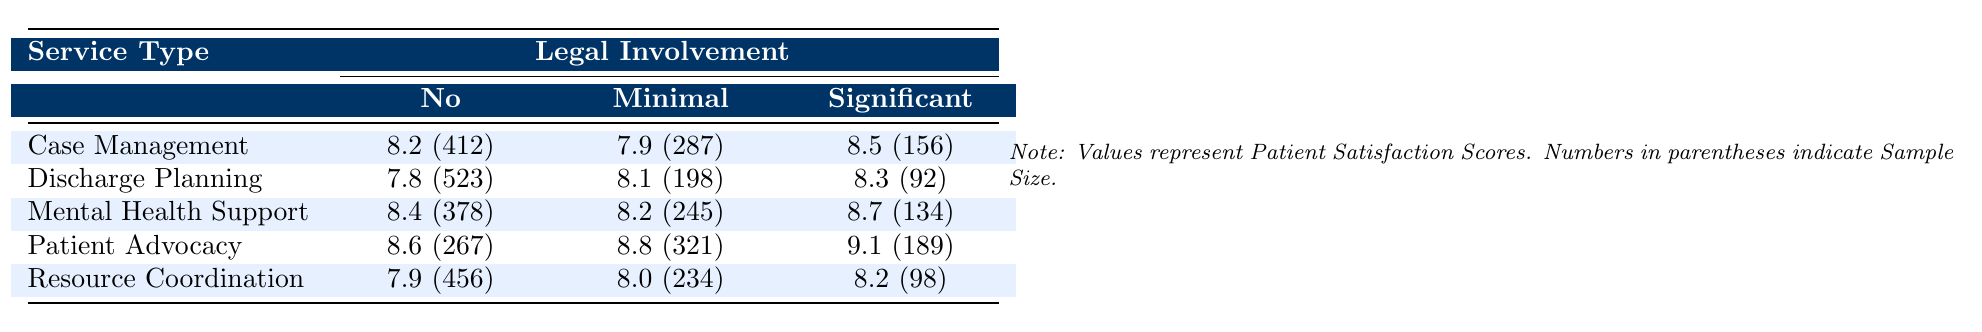What is the satisfaction score for Case Management with No Legal Involvement? The satisfaction score listed under Case Management for No Legal Involvement is 8.2.
Answer: 8.2 How many patients participated in the Discharge Planning with Significant Legal Involvement? The sample size for Discharge Planning with Significant Legal Involvement is 92 patients.
Answer: 92 What is the highest satisfaction score among the service types? The highest satisfaction score is 9.1 for Patient Advocacy with Significant Legal Involvement.
Answer: 9.1 What is the average satisfaction score for Mental Health Support across all levels of legal involvement? The scores are 8.4, 8.2, and 8.7 for the three levels. Summing them gives 25.3, and dividing by 3 results in an average score of approximately 8.43.
Answer: 8.43 Is the satisfaction score for Resource Coordination with Minimal Legal Involvement higher than that for Case Management with No Legal Involvement? The satisfaction score for Resource Coordination with Minimal Legal Involvement is 8.0, while Case Management with No Legal Involvement is 8.2, so it is not higher.
Answer: No Which service type has the lowest satisfaction score when there is Significant Legal Involvement? For Significant Legal Involvement, the satisfaction scores are 8.5 (Case Management), 8.3 (Discharge Planning), 8.7 (Mental Health Support), 9.1 (Patient Advocacy), and 8.2 (Resource Coordination). The lowest is 8.2 from Resource Coordination.
Answer: Resource Coordination If we consider all service types, how does the satisfaction score for Minimal Legal Involvement in Patient Advocacy compare to that in Discharge Planning? The satisfaction score for Patient Advocacy with Minimal Legal Involvement is 8.8, while that for Discharge Planning is 8.1. Thus, Patient Advocacy has a higher score.
Answer: Higher What is the total sample size for all cases with No Legal Involvement across all service types? The sample sizes for No Legal Involvement are 412, 523, 378, 267, and 456. Adding these gives a total of 2036.
Answer: 2036 Who has the highest satisfaction score among all service and legal involvement combinations? The highest satisfaction score is 9.1 from Patient Advocacy with Significant Legal Involvement.
Answer: 9.1 Which legal involvement level shows the highest patient satisfaction score for any service type? The highest score is 9.1 for Patient Advocacy with Significant Legal Involvement.
Answer: 9.1 